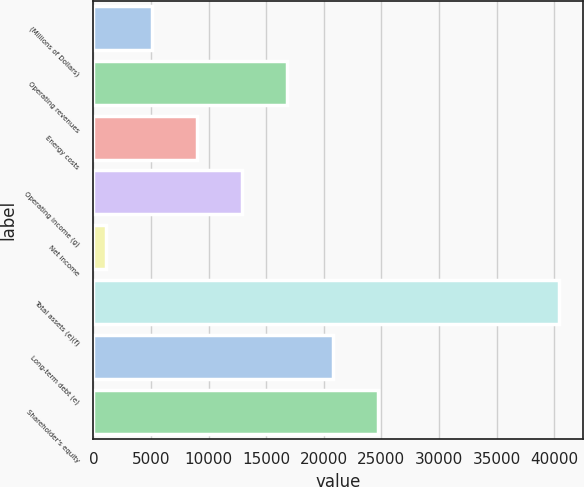<chart> <loc_0><loc_0><loc_500><loc_500><bar_chart><fcel>(Millions of Dollars)<fcel>Operating revenues<fcel>Energy costs<fcel>Operating income (g)<fcel>Net income<fcel>Total assets (e)(f)<fcel>Long-term debt (e)<fcel>Shareholder's equity<nl><fcel>5038.7<fcel>16842.8<fcel>8973.4<fcel>12908.1<fcel>1104<fcel>40451<fcel>20777.5<fcel>24712.2<nl></chart> 